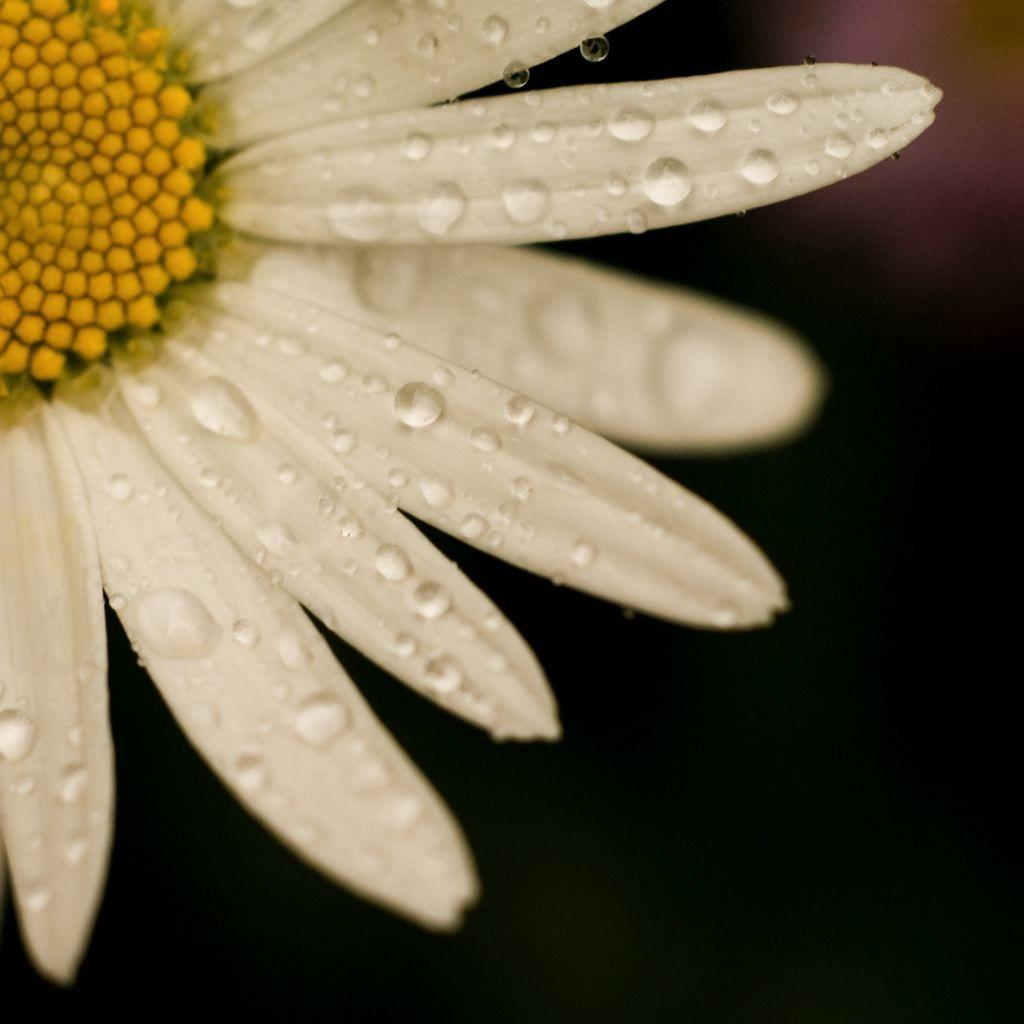What is the main subject of the picture? The main subject of the picture is a flower. Can you describe the flower in the image? The flower has water drops on it. What is the appearance of the background in the image? The background of the image is blurred. What color is the cushion that the manager is sitting on in the image? There is no cushion or manager present in the image; it features a flower with water drops and a blurred background. 